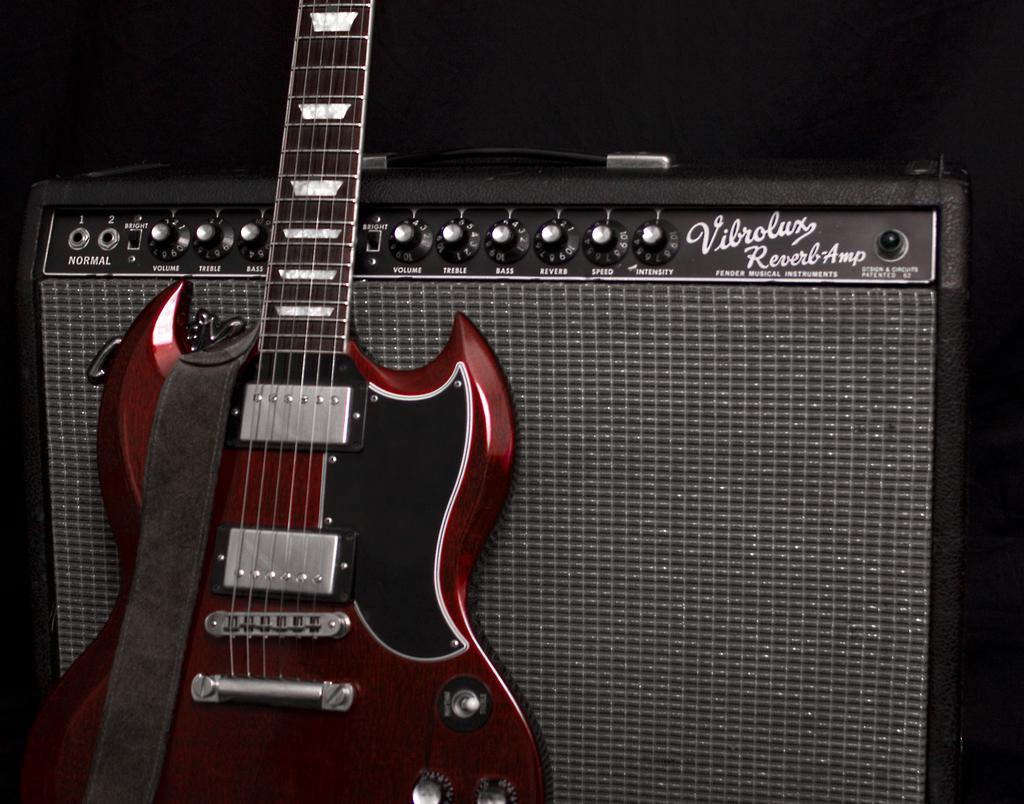What musical instrument is present in the image? There is a guitar in the image. What accompanies the guitar in the image? There is a guitar amplifier in the image. What can be inferred about the lighting conditions in the image? The background of the image is dark. Can you see a circle of flowers around the guitar amplifier in the image? There is no circle of flowers present around the guitar amplifier in the image. 